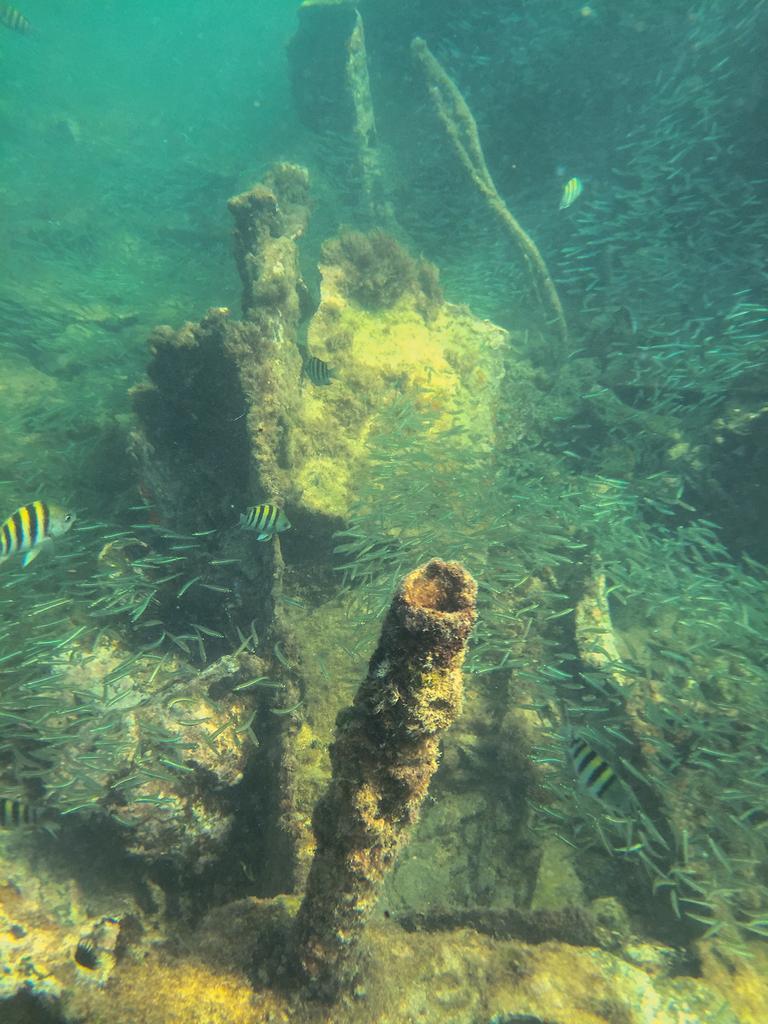How would you summarize this image in a sentence or two? This image is taken underwater. In this image there are many fishes and marine creatures in the water. 